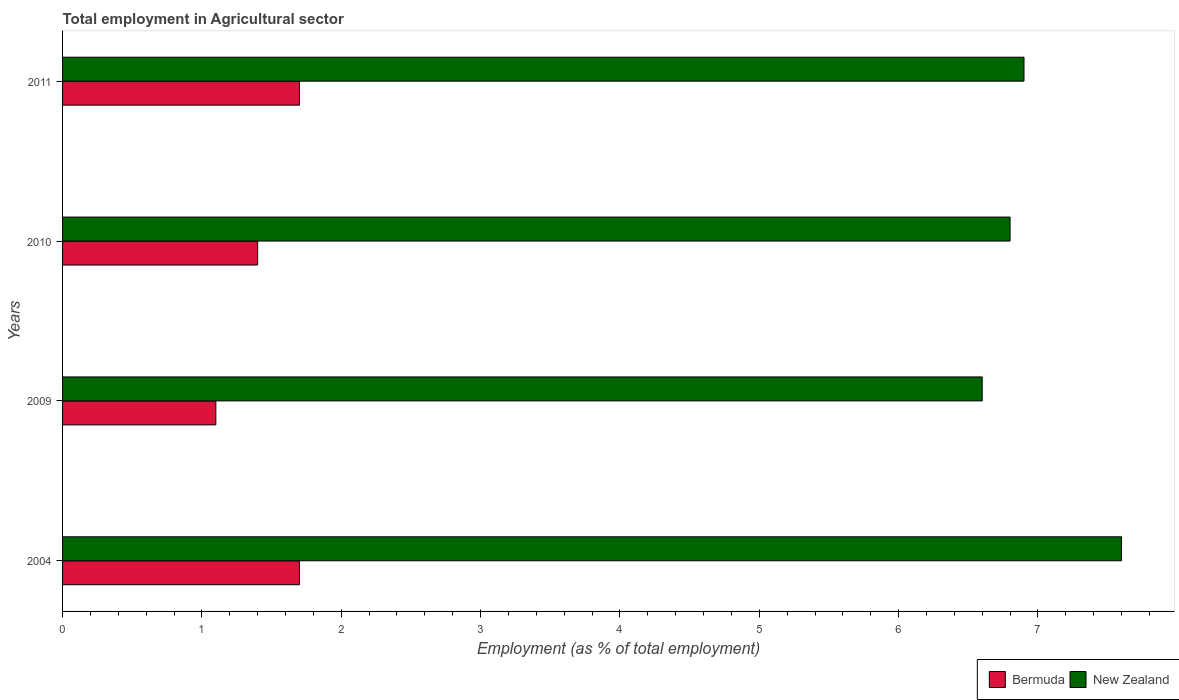Are the number of bars on each tick of the Y-axis equal?
Your response must be concise. Yes. How many bars are there on the 1st tick from the top?
Make the answer very short. 2. How many bars are there on the 2nd tick from the bottom?
Offer a terse response. 2. In how many cases, is the number of bars for a given year not equal to the number of legend labels?
Provide a succinct answer. 0. What is the employment in agricultural sector in Bermuda in 2010?
Your response must be concise. 1.4. Across all years, what is the maximum employment in agricultural sector in New Zealand?
Give a very brief answer. 7.6. Across all years, what is the minimum employment in agricultural sector in Bermuda?
Provide a short and direct response. 1.1. In which year was the employment in agricultural sector in Bermuda minimum?
Provide a short and direct response. 2009. What is the total employment in agricultural sector in New Zealand in the graph?
Make the answer very short. 27.9. What is the difference between the employment in agricultural sector in Bermuda in 2004 and that in 2011?
Your response must be concise. 0. What is the difference between the employment in agricultural sector in Bermuda in 2004 and the employment in agricultural sector in New Zealand in 2010?
Make the answer very short. -5.1. What is the average employment in agricultural sector in New Zealand per year?
Make the answer very short. 6.98. In the year 2009, what is the difference between the employment in agricultural sector in Bermuda and employment in agricultural sector in New Zealand?
Keep it short and to the point. -5.5. In how many years, is the employment in agricultural sector in New Zealand greater than 2 %?
Ensure brevity in your answer.  4. What is the ratio of the employment in agricultural sector in Bermuda in 2004 to that in 2009?
Offer a terse response. 1.55. Is the employment in agricultural sector in New Zealand in 2004 less than that in 2011?
Provide a short and direct response. No. Is the difference between the employment in agricultural sector in Bermuda in 2010 and 2011 greater than the difference between the employment in agricultural sector in New Zealand in 2010 and 2011?
Your answer should be compact. No. What is the difference between the highest and the second highest employment in agricultural sector in New Zealand?
Provide a short and direct response. 0.7. What is the difference between the highest and the lowest employment in agricultural sector in Bermuda?
Your answer should be very brief. 0.6. In how many years, is the employment in agricultural sector in New Zealand greater than the average employment in agricultural sector in New Zealand taken over all years?
Ensure brevity in your answer.  1. Is the sum of the employment in agricultural sector in Bermuda in 2009 and 2011 greater than the maximum employment in agricultural sector in New Zealand across all years?
Make the answer very short. No. What does the 1st bar from the top in 2004 represents?
Offer a very short reply. New Zealand. What does the 2nd bar from the bottom in 2010 represents?
Make the answer very short. New Zealand. Are all the bars in the graph horizontal?
Ensure brevity in your answer.  Yes. Are the values on the major ticks of X-axis written in scientific E-notation?
Your answer should be compact. No. Does the graph contain any zero values?
Make the answer very short. No. Where does the legend appear in the graph?
Provide a short and direct response. Bottom right. How many legend labels are there?
Provide a short and direct response. 2. What is the title of the graph?
Your answer should be very brief. Total employment in Agricultural sector. What is the label or title of the X-axis?
Keep it short and to the point. Employment (as % of total employment). What is the label or title of the Y-axis?
Offer a very short reply. Years. What is the Employment (as % of total employment) in Bermuda in 2004?
Your response must be concise. 1.7. What is the Employment (as % of total employment) in New Zealand in 2004?
Your answer should be very brief. 7.6. What is the Employment (as % of total employment) of Bermuda in 2009?
Your answer should be very brief. 1.1. What is the Employment (as % of total employment) in New Zealand in 2009?
Offer a terse response. 6.6. What is the Employment (as % of total employment) of Bermuda in 2010?
Your answer should be compact. 1.4. What is the Employment (as % of total employment) in New Zealand in 2010?
Your answer should be compact. 6.8. What is the Employment (as % of total employment) in Bermuda in 2011?
Keep it short and to the point. 1.7. What is the Employment (as % of total employment) in New Zealand in 2011?
Your answer should be very brief. 6.9. Across all years, what is the maximum Employment (as % of total employment) in Bermuda?
Your response must be concise. 1.7. Across all years, what is the maximum Employment (as % of total employment) of New Zealand?
Your answer should be compact. 7.6. Across all years, what is the minimum Employment (as % of total employment) in Bermuda?
Provide a short and direct response. 1.1. Across all years, what is the minimum Employment (as % of total employment) in New Zealand?
Ensure brevity in your answer.  6.6. What is the total Employment (as % of total employment) of New Zealand in the graph?
Make the answer very short. 27.9. What is the difference between the Employment (as % of total employment) of New Zealand in 2004 and that in 2009?
Give a very brief answer. 1. What is the difference between the Employment (as % of total employment) of New Zealand in 2004 and that in 2010?
Your response must be concise. 0.8. What is the difference between the Employment (as % of total employment) in New Zealand in 2004 and that in 2011?
Provide a short and direct response. 0.7. What is the difference between the Employment (as % of total employment) of New Zealand in 2009 and that in 2010?
Make the answer very short. -0.2. What is the difference between the Employment (as % of total employment) of Bermuda in 2009 and that in 2011?
Your answer should be very brief. -0.6. What is the difference between the Employment (as % of total employment) in New Zealand in 2010 and that in 2011?
Your response must be concise. -0.1. What is the difference between the Employment (as % of total employment) in Bermuda in 2004 and the Employment (as % of total employment) in New Zealand in 2010?
Your response must be concise. -5.1. What is the difference between the Employment (as % of total employment) in Bermuda in 2004 and the Employment (as % of total employment) in New Zealand in 2011?
Offer a very short reply. -5.2. What is the difference between the Employment (as % of total employment) in Bermuda in 2009 and the Employment (as % of total employment) in New Zealand in 2010?
Provide a short and direct response. -5.7. What is the average Employment (as % of total employment) in Bermuda per year?
Your answer should be very brief. 1.48. What is the average Employment (as % of total employment) of New Zealand per year?
Your answer should be compact. 6.97. In the year 2010, what is the difference between the Employment (as % of total employment) of Bermuda and Employment (as % of total employment) of New Zealand?
Provide a succinct answer. -5.4. What is the ratio of the Employment (as % of total employment) of Bermuda in 2004 to that in 2009?
Ensure brevity in your answer.  1.55. What is the ratio of the Employment (as % of total employment) in New Zealand in 2004 to that in 2009?
Keep it short and to the point. 1.15. What is the ratio of the Employment (as % of total employment) in Bermuda in 2004 to that in 2010?
Ensure brevity in your answer.  1.21. What is the ratio of the Employment (as % of total employment) in New Zealand in 2004 to that in 2010?
Make the answer very short. 1.12. What is the ratio of the Employment (as % of total employment) in Bermuda in 2004 to that in 2011?
Offer a terse response. 1. What is the ratio of the Employment (as % of total employment) in New Zealand in 2004 to that in 2011?
Offer a very short reply. 1.1. What is the ratio of the Employment (as % of total employment) of Bermuda in 2009 to that in 2010?
Keep it short and to the point. 0.79. What is the ratio of the Employment (as % of total employment) of New Zealand in 2009 to that in 2010?
Offer a very short reply. 0.97. What is the ratio of the Employment (as % of total employment) in Bermuda in 2009 to that in 2011?
Your response must be concise. 0.65. What is the ratio of the Employment (as % of total employment) in New Zealand in 2009 to that in 2011?
Provide a succinct answer. 0.96. What is the ratio of the Employment (as % of total employment) of Bermuda in 2010 to that in 2011?
Make the answer very short. 0.82. What is the ratio of the Employment (as % of total employment) in New Zealand in 2010 to that in 2011?
Offer a very short reply. 0.99. What is the difference between the highest and the lowest Employment (as % of total employment) in Bermuda?
Ensure brevity in your answer.  0.6. 